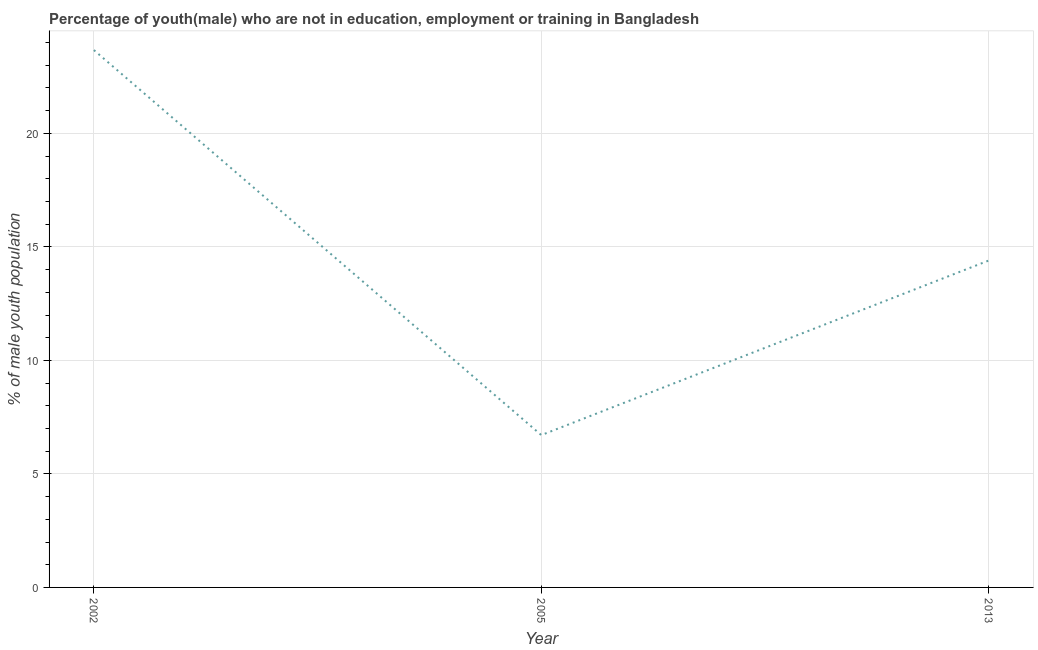What is the unemployed male youth population in 2002?
Offer a very short reply. 23.67. Across all years, what is the maximum unemployed male youth population?
Offer a very short reply. 23.67. Across all years, what is the minimum unemployed male youth population?
Offer a very short reply. 6.71. What is the sum of the unemployed male youth population?
Provide a succinct answer. 44.78. What is the difference between the unemployed male youth population in 2002 and 2013?
Give a very brief answer. 9.27. What is the average unemployed male youth population per year?
Ensure brevity in your answer.  14.93. What is the median unemployed male youth population?
Make the answer very short. 14.4. In how many years, is the unemployed male youth population greater than 2 %?
Ensure brevity in your answer.  3. Do a majority of the years between 2013 and 2005 (inclusive) have unemployed male youth population greater than 15 %?
Provide a short and direct response. No. What is the ratio of the unemployed male youth population in 2005 to that in 2013?
Offer a very short reply. 0.47. What is the difference between the highest and the second highest unemployed male youth population?
Provide a succinct answer. 9.27. Is the sum of the unemployed male youth population in 2005 and 2013 greater than the maximum unemployed male youth population across all years?
Give a very brief answer. No. What is the difference between the highest and the lowest unemployed male youth population?
Offer a terse response. 16.96. In how many years, is the unemployed male youth population greater than the average unemployed male youth population taken over all years?
Your answer should be compact. 1. How many lines are there?
Ensure brevity in your answer.  1. Does the graph contain any zero values?
Your answer should be very brief. No. Does the graph contain grids?
Your answer should be compact. Yes. What is the title of the graph?
Your answer should be compact. Percentage of youth(male) who are not in education, employment or training in Bangladesh. What is the label or title of the Y-axis?
Keep it short and to the point. % of male youth population. What is the % of male youth population of 2002?
Your answer should be compact. 23.67. What is the % of male youth population of 2005?
Ensure brevity in your answer.  6.71. What is the % of male youth population of 2013?
Your answer should be compact. 14.4. What is the difference between the % of male youth population in 2002 and 2005?
Provide a succinct answer. 16.96. What is the difference between the % of male youth population in 2002 and 2013?
Offer a very short reply. 9.27. What is the difference between the % of male youth population in 2005 and 2013?
Provide a succinct answer. -7.69. What is the ratio of the % of male youth population in 2002 to that in 2005?
Your answer should be very brief. 3.53. What is the ratio of the % of male youth population in 2002 to that in 2013?
Provide a succinct answer. 1.64. What is the ratio of the % of male youth population in 2005 to that in 2013?
Give a very brief answer. 0.47. 